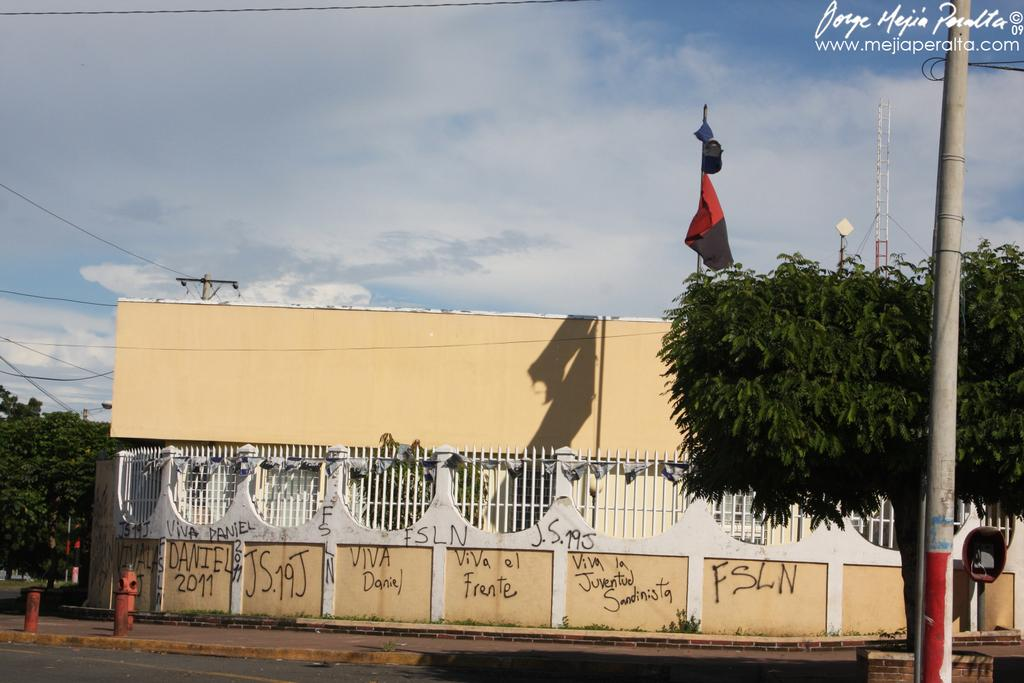What object can be seen in the image that is used for fire safety? There is a fire hydrant in the image. What type of structures are present in the image? There are poles, a tower, and a building in the image. What type of vegetation can be seen in the image? There are trees in the image. What is attached to the poles in the image? There are wires attached to a pole in the image. What can be seen in the background of the image? The sky is visible in the background of the image. Is there any additional information or markings on the image? Yes, there is a watermark on the image. What type of grass is growing on the fire hydrant in the image? There is no grass growing on the fire hydrant in the image. Can you see a veil covering the tower in the image? There is no veil present in the image; the tower is visible without any covering. 